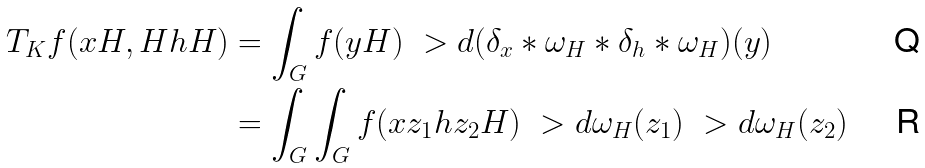Convert formula to latex. <formula><loc_0><loc_0><loc_500><loc_500>T _ { K } f ( x H , H h H ) & = \int _ { G } f ( y H ) \ > d ( \delta _ { x } * \omega _ { H } * \delta _ { h } * \omega _ { H } ) ( y ) \\ & = \int _ { G } \int _ { G } f ( x z _ { 1 } h z _ { 2 } H ) \ > d \omega _ { H } ( z _ { 1 } ) \ > d \omega _ { H } ( z _ { 2 } )</formula> 